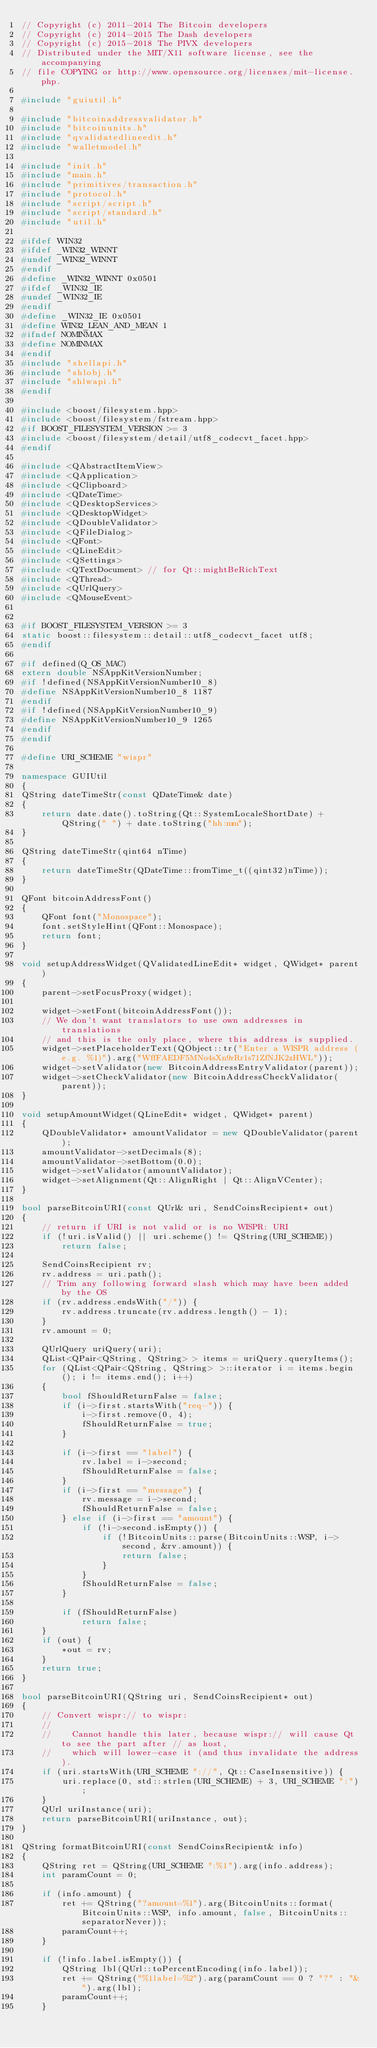Convert code to text. <code><loc_0><loc_0><loc_500><loc_500><_C++_>// Copyright (c) 2011-2014 The Bitcoin developers
// Copyright (c) 2014-2015 The Dash developers
// Copyright (c) 2015-2018 The PIVX developers
// Distributed under the MIT/X11 software license, see the accompanying
// file COPYING or http://www.opensource.org/licenses/mit-license.php.

#include "guiutil.h"

#include "bitcoinaddressvalidator.h"
#include "bitcoinunits.h"
#include "qvalidatedlineedit.h"
#include "walletmodel.h"

#include "init.h"
#include "main.h"
#include "primitives/transaction.h"
#include "protocol.h"
#include "script/script.h"
#include "script/standard.h"
#include "util.h"

#ifdef WIN32
#ifdef _WIN32_WINNT
#undef _WIN32_WINNT
#endif
#define _WIN32_WINNT 0x0501
#ifdef _WIN32_IE
#undef _WIN32_IE
#endif
#define _WIN32_IE 0x0501
#define WIN32_LEAN_AND_MEAN 1
#ifndef NOMINMAX
#define NOMINMAX
#endif
#include "shellapi.h"
#include "shlobj.h"
#include "shlwapi.h"
#endif

#include <boost/filesystem.hpp>
#include <boost/filesystem/fstream.hpp>
#if BOOST_FILESYSTEM_VERSION >= 3
#include <boost/filesystem/detail/utf8_codecvt_facet.hpp>
#endif

#include <QAbstractItemView>
#include <QApplication>
#include <QClipboard>
#include <QDateTime>
#include <QDesktopServices>
#include <QDesktopWidget>
#include <QDoubleValidator>
#include <QFileDialog>
#include <QFont>
#include <QLineEdit>
#include <QSettings>
#include <QTextDocument> // for Qt::mightBeRichText
#include <QThread>
#include <QUrlQuery>
#include <QMouseEvent>


#if BOOST_FILESYSTEM_VERSION >= 3
static boost::filesystem::detail::utf8_codecvt_facet utf8;
#endif

#if defined(Q_OS_MAC)
extern double NSAppKitVersionNumber;
#if !defined(NSAppKitVersionNumber10_8)
#define NSAppKitVersionNumber10_8 1187
#endif
#if !defined(NSAppKitVersionNumber10_9)
#define NSAppKitVersionNumber10_9 1265
#endif
#endif

#define URI_SCHEME "wispr"

namespace GUIUtil
{
QString dateTimeStr(const QDateTime& date)
{
    return date.date().toString(Qt::SystemLocaleShortDate) + QString(" ") + date.toString("hh:mm");
}

QString dateTimeStr(qint64 nTime)
{
    return dateTimeStr(QDateTime::fromTime_t((qint32)nTime));
}

QFont bitcoinAddressFont()
{
    QFont font("Monospace");
    font.setStyleHint(QFont::Monospace);
    return font;
}

void setupAddressWidget(QValidatedLineEdit* widget, QWidget* parent)
{
    parent->setFocusProxy(widget);

    widget->setFont(bitcoinAddressFont());
    // We don't want translators to use own addresses in translations
    // and this is the only place, where this address is supplied.
    widget->setPlaceholderText(QObject::tr("Enter a WISPR address (e.g. %1)").arg("WffFAEDF5MNo4sXn9rRr1s71ZfNJK2zHWL"));
    widget->setValidator(new BitcoinAddressEntryValidator(parent));
    widget->setCheckValidator(new BitcoinAddressCheckValidator(parent));
}

void setupAmountWidget(QLineEdit* widget, QWidget* parent)
{
    QDoubleValidator* amountValidator = new QDoubleValidator(parent);
    amountValidator->setDecimals(8);
    amountValidator->setBottom(0.0);
    widget->setValidator(amountValidator);
    widget->setAlignment(Qt::AlignRight | Qt::AlignVCenter);
}

bool parseBitcoinURI(const QUrl& uri, SendCoinsRecipient* out)
{
    // return if URI is not valid or is no WISPR: URI
    if (!uri.isValid() || uri.scheme() != QString(URI_SCHEME))
        return false;

    SendCoinsRecipient rv;
    rv.address = uri.path();
    // Trim any following forward slash which may have been added by the OS
    if (rv.address.endsWith("/")) {
        rv.address.truncate(rv.address.length() - 1);
    }
    rv.amount = 0;

    QUrlQuery uriQuery(uri);
    QList<QPair<QString, QString> > items = uriQuery.queryItems();
    for (QList<QPair<QString, QString> >::iterator i = items.begin(); i != items.end(); i++)
    {
        bool fShouldReturnFalse = false;
        if (i->first.startsWith("req-")) {
            i->first.remove(0, 4);
            fShouldReturnFalse = true;
        }

        if (i->first == "label") {
            rv.label = i->second;
            fShouldReturnFalse = false;
        }
        if (i->first == "message") {
            rv.message = i->second;
            fShouldReturnFalse = false;
        } else if (i->first == "amount") {
            if (!i->second.isEmpty()) {
                if (!BitcoinUnits::parse(BitcoinUnits::WSP, i->second, &rv.amount)) {
                    return false;
                }
            }
            fShouldReturnFalse = false;
        }

        if (fShouldReturnFalse)
            return false;
    }
    if (out) {
        *out = rv;
    }
    return true;
}

bool parseBitcoinURI(QString uri, SendCoinsRecipient* out)
{
    // Convert wispr:// to wispr:
    //
    //    Cannot handle this later, because wispr:// will cause Qt to see the part after // as host,
    //    which will lower-case it (and thus invalidate the address).
    if (uri.startsWith(URI_SCHEME "://", Qt::CaseInsensitive)) {
        uri.replace(0, std::strlen(URI_SCHEME) + 3, URI_SCHEME ":");
    }
    QUrl uriInstance(uri);
    return parseBitcoinURI(uriInstance, out);
}

QString formatBitcoinURI(const SendCoinsRecipient& info)
{
    QString ret = QString(URI_SCHEME ":%1").arg(info.address);
    int paramCount = 0;

    if (info.amount) {
        ret += QString("?amount=%1").arg(BitcoinUnits::format(BitcoinUnits::WSP, info.amount, false, BitcoinUnits::separatorNever));
        paramCount++;
    }

    if (!info.label.isEmpty()) {
        QString lbl(QUrl::toPercentEncoding(info.label));
        ret += QString("%1label=%2").arg(paramCount == 0 ? "?" : "&").arg(lbl);
        paramCount++;
    }
</code> 